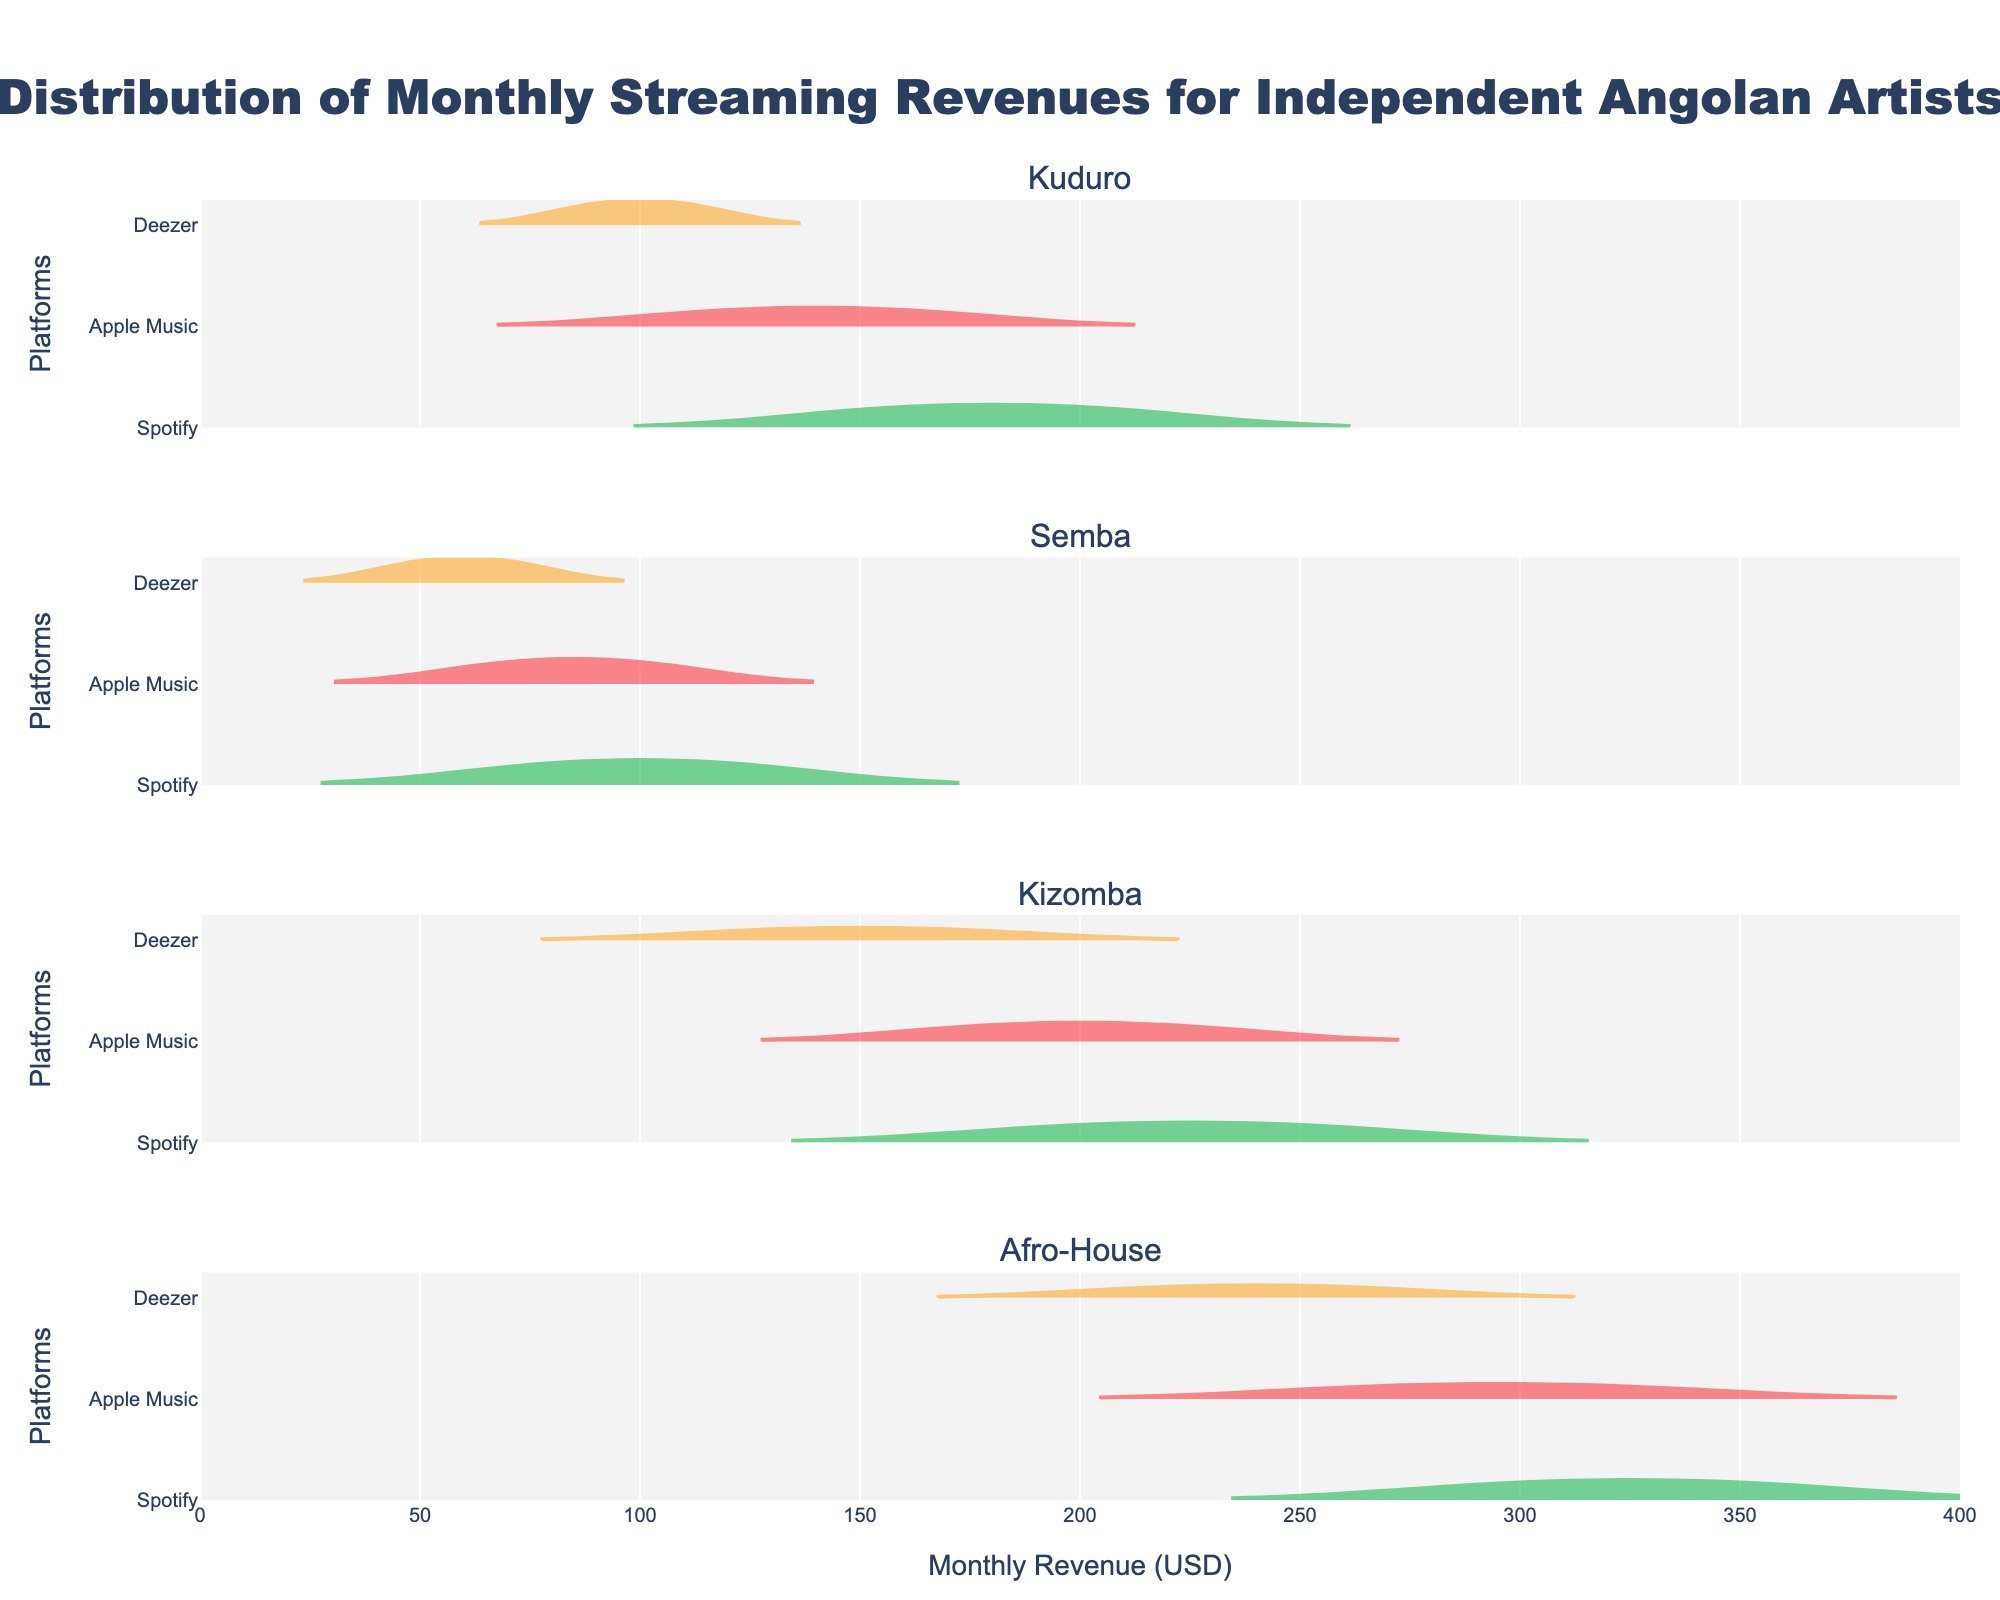What is the musical style with the highest median monthly revenue on Spotify? To determine this, check the position of the central tendency (median) for the Spotify violin plots. The highest median will be located furthest to the right along the horizontal axis. In this case, Afro-House Spotify has the highest median.
Answer: Afro-House How does the median revenue for Kizomba artists on Apple Music compare to that on Deezer? Look at the central positions of the two Kizomba violin plots for Apple Music and Deezer. The midpoint for Deezer is slightly left of 150, while for Apple Music it's closer to 200.
Answer: Apple Music median is higher Which platform has the least variability in monthly revenues for Kuduro artists? Check the spread of the violin plots for Kuduro. Spotify has a wider spread, while Apple Music and Deezer have narrower distributions. Deezer appears to have the smallest variability.
Answer: Deezer Among the styles shown, which has the overall highest maximum revenue value across all platforms? Look at the farthest right end of all violin plots. The highest point is in Afro-House on Spotify, reaching 350.
Answer: Afro-House Which platform generates the lowest median revenue for Semba artists? Examine the center of the Semba violin plots. The plot for Deezer is centered around 60, which is lower than Apple Music and Spotify.
Answer: Deezer Is there any platform where the monthly revenue distribution for Kuduro artists is bi-modal or multi-modal? Evaluate the shape of the violin plots for Kuduro artists across platforms. None of the distributions appear to have multiple peaks; they are all unimodal.
Answer: No Compare the spread (interquartile range) for monthly revenues between Afro-House and Kizomba on Apple Music. Which has a larger spread? Look at the width of the violin plots. The Afro-House plot on Apple Music is more spread out compared to Kizomba, indicating a larger interquartile range.
Answer: Afro-House For which musical style does Deezer show the highest variability in monthly revenues? Compare all Deezer violin plots across different styles. Afro-House appears to have the widest distribution on Deezer, indicating the highest variability.
Answer: Afro-House 